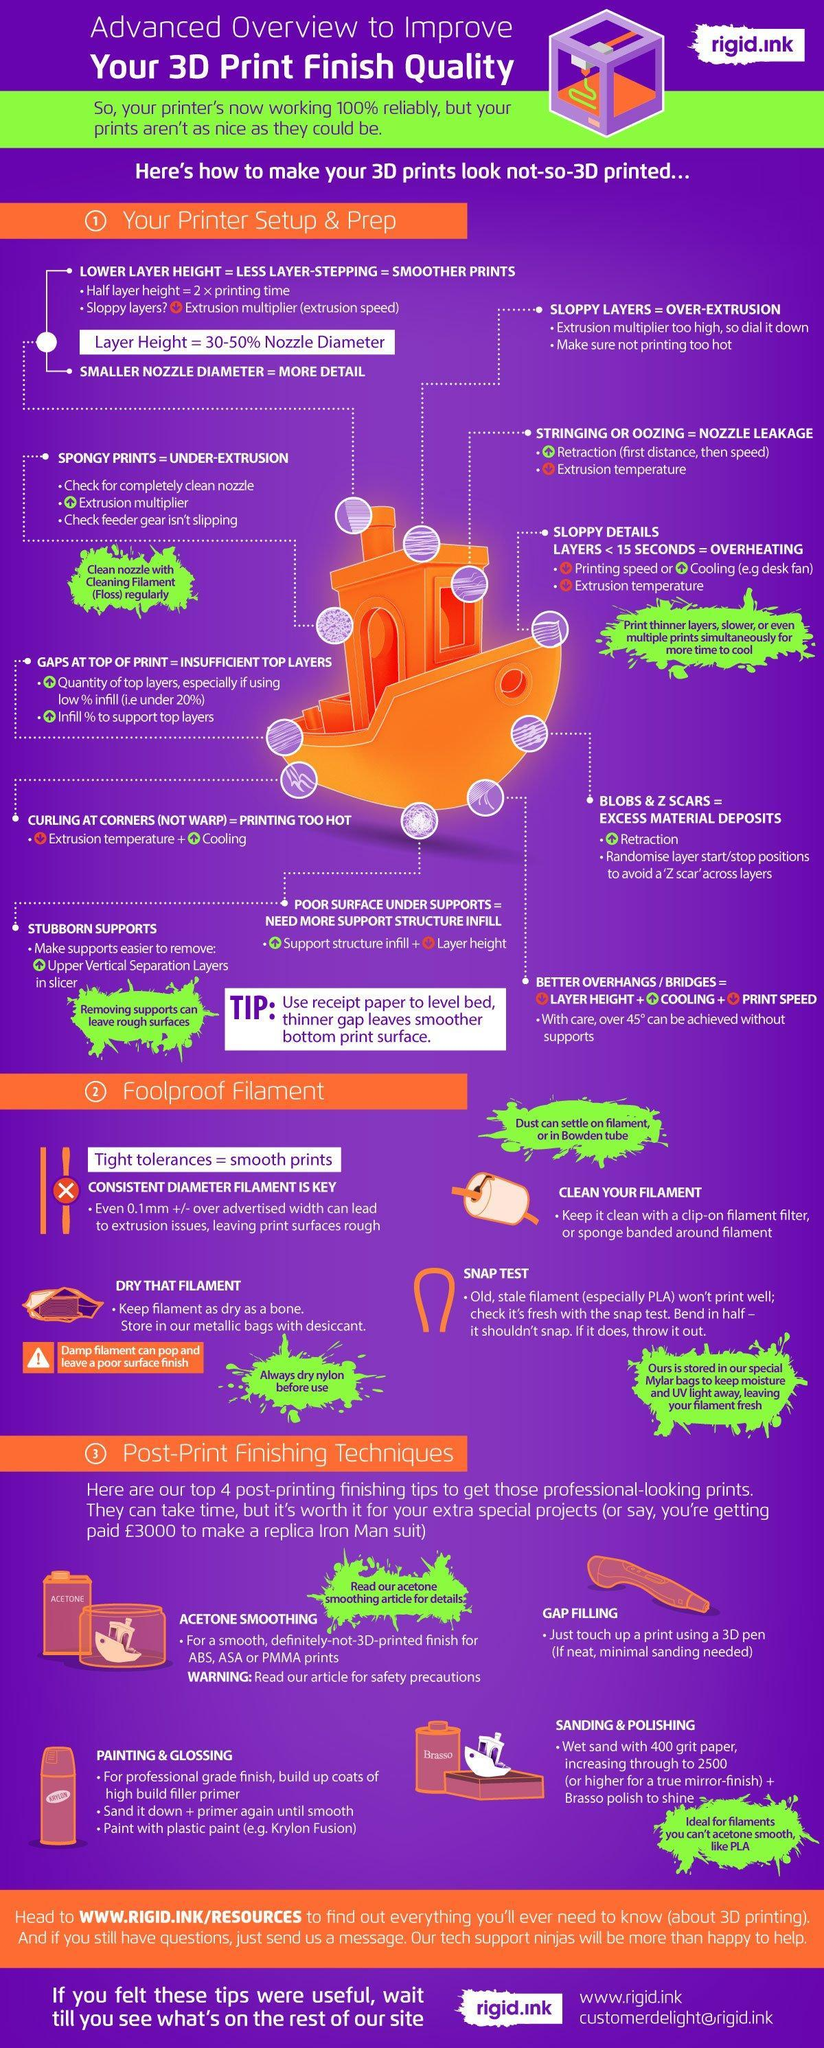For what purpose would you need to touch up using a 3D pen?
Answer the question with a short phrase. Gap filling In what should filament be stored to keep it dry? metallic bags with desiccant What type filament will snap when bent in half? stale filament 